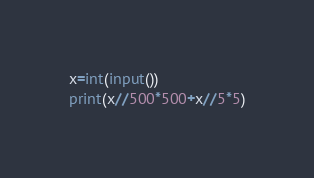Convert code to text. <code><loc_0><loc_0><loc_500><loc_500><_Python_>x=int(input())
print(x//500*500+x//5*5)</code> 